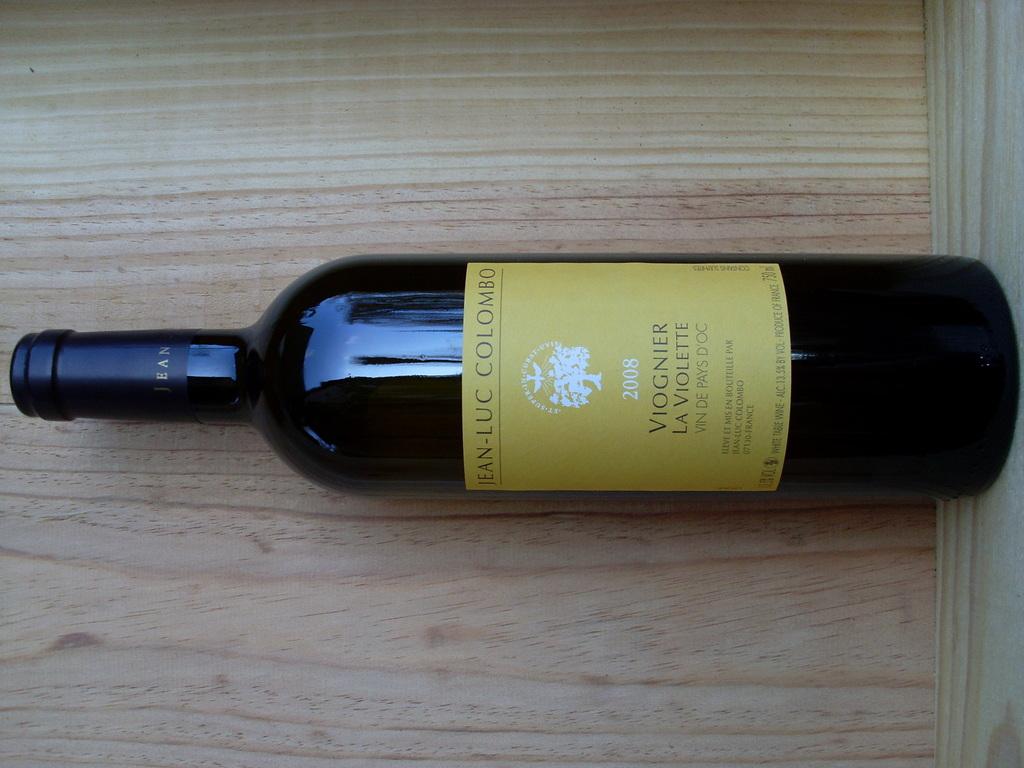What year was this wine made?
Give a very brief answer. 2008. 